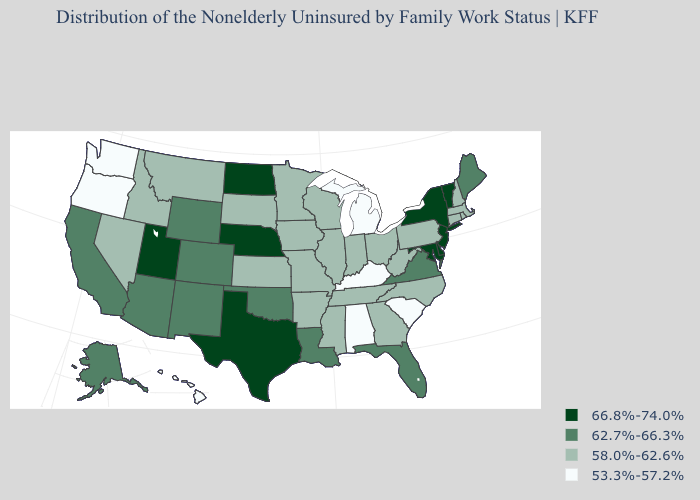Is the legend a continuous bar?
Quick response, please. No. Name the states that have a value in the range 58.0%-62.6%?
Keep it brief. Arkansas, Connecticut, Georgia, Idaho, Illinois, Indiana, Iowa, Kansas, Massachusetts, Minnesota, Mississippi, Missouri, Montana, Nevada, New Hampshire, North Carolina, Ohio, Pennsylvania, Rhode Island, South Dakota, Tennessee, West Virginia, Wisconsin. Does Louisiana have the same value as Virginia?
Short answer required. Yes. Among the states that border New Jersey , which have the lowest value?
Keep it brief. Pennsylvania. Does the first symbol in the legend represent the smallest category?
Concise answer only. No. Which states have the lowest value in the USA?
Write a very short answer. Alabama, Hawaii, Kentucky, Michigan, Oregon, South Carolina, Washington. Which states have the lowest value in the Northeast?
Answer briefly. Connecticut, Massachusetts, New Hampshire, Pennsylvania, Rhode Island. What is the value of New Hampshire?
Give a very brief answer. 58.0%-62.6%. What is the value of Minnesota?
Keep it brief. 58.0%-62.6%. Name the states that have a value in the range 66.8%-74.0%?
Short answer required. Delaware, Maryland, Nebraska, New Jersey, New York, North Dakota, Texas, Utah, Vermont. Name the states that have a value in the range 66.8%-74.0%?
Concise answer only. Delaware, Maryland, Nebraska, New Jersey, New York, North Dakota, Texas, Utah, Vermont. Does the first symbol in the legend represent the smallest category?
Answer briefly. No. What is the value of Oklahoma?
Keep it brief. 62.7%-66.3%. Among the states that border New Mexico , which have the highest value?
Short answer required. Texas, Utah. 